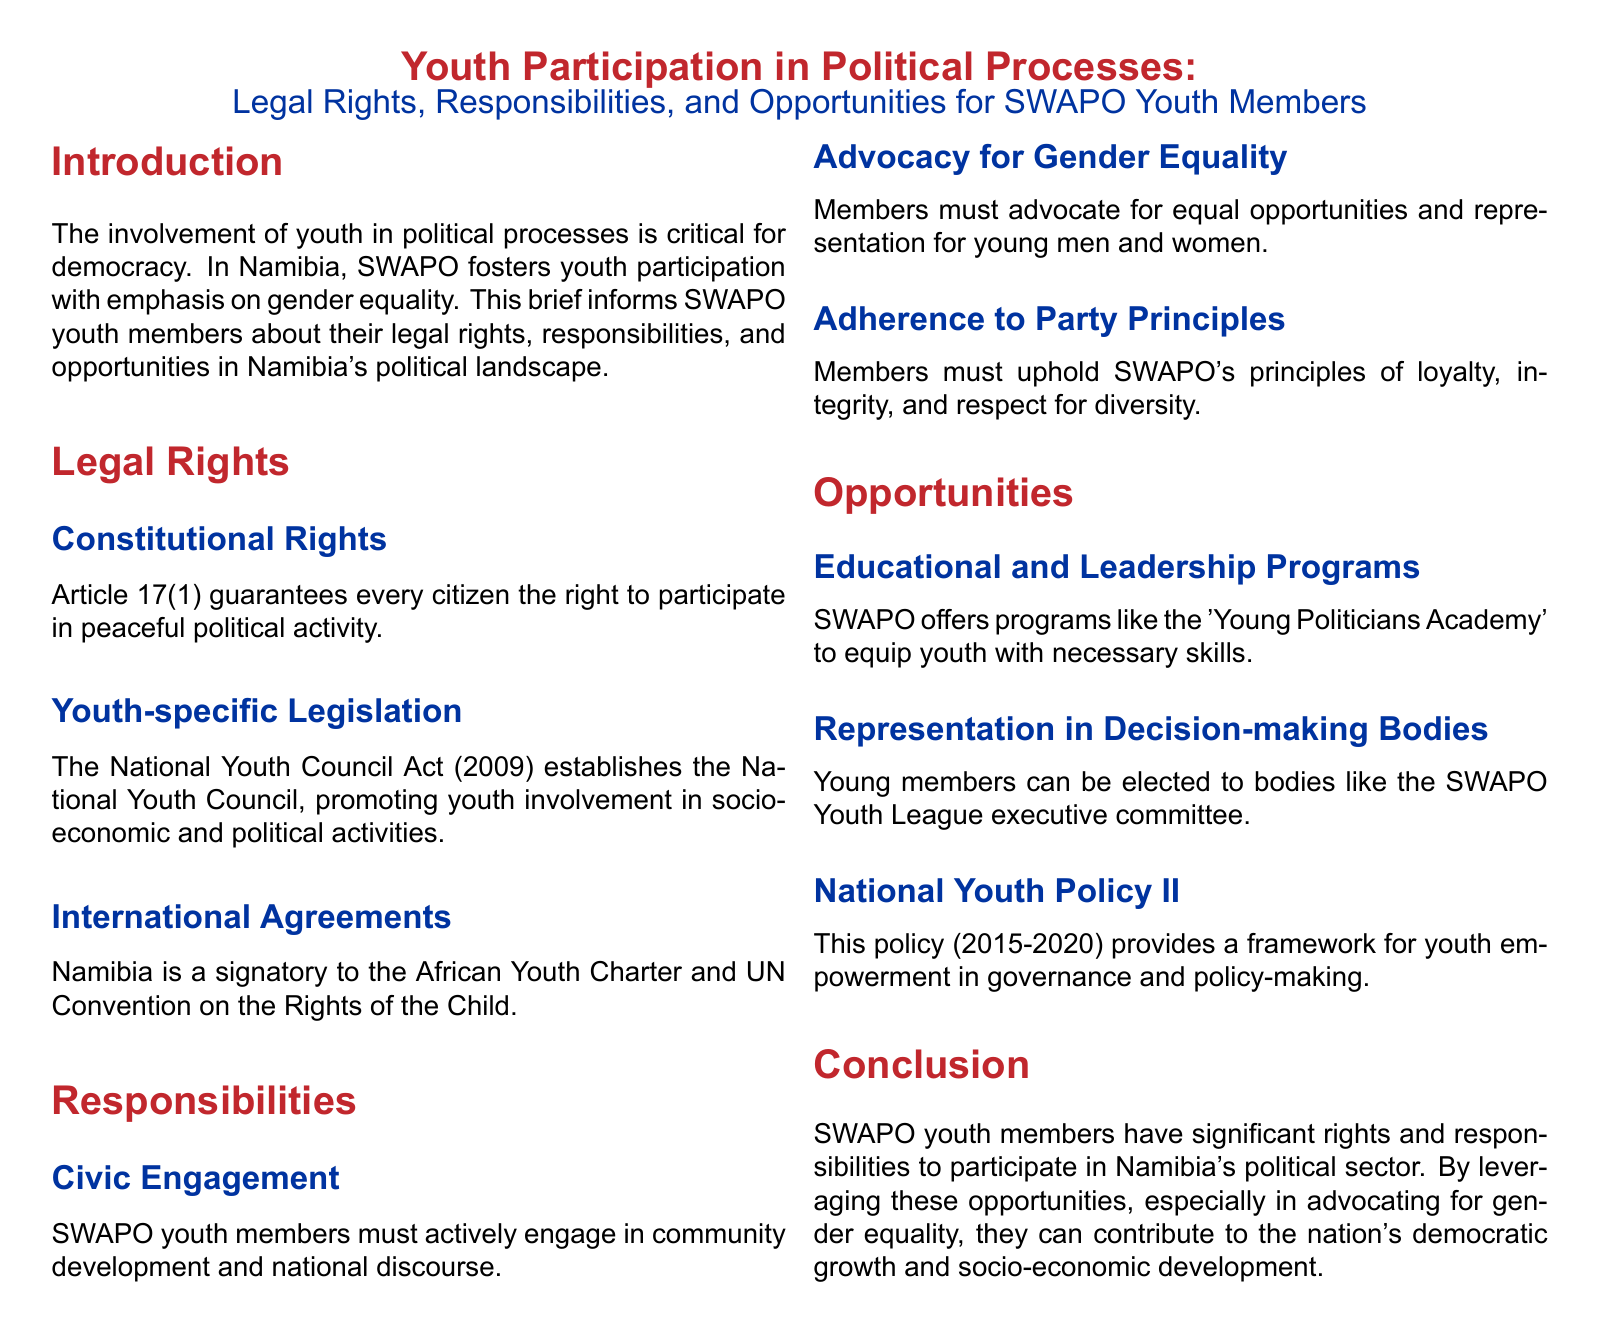What guarantees citizens the right to political activity? Article 17(1) of the Namibian Constitution guarantees every citizen the right to participate in peaceful political activity.
Answer: Article 17(1) What act promotes youth involvement in socio-economic and political activities? The National Youth Council Act (2009) establishes the National Youth Council, promoting youth involvement in socio-economic and political activities.
Answer: National Youth Council Act (2009) Which international agreement relates to the rights of children? Namibia is a signatory to the UN Convention on the Rights of the Child, which outlines rights for youth.
Answer: UN Convention on the Rights of the Child What program does SWAPO offer for youth to learn leadership skills? The 'Young Politicians Academy' is a program offered by SWAPO to equip youth with necessary skills.
Answer: Young Politicians Academy What should SWAPO youth members advocate for regarding gender? Members must advocate for equal opportunities and representation for young men and women, emphasizing gender equality.
Answer: Gender equality How long is the National Youth Policy II in effect? The National Youth Policy II is in effect from 2015 to 2020, providing a framework for youth empowerment.
Answer: 2015-2020 What party principles must SWAPO youth members uphold? Members must uphold principles of loyalty, integrity, and respect for diversity as mandated by SWAPO.
Answer: Loyalty, integrity, respect for diversity What is a responsibility of SWAPO youth members? SWAPO youth members must actively engage in community development and national discourse.
Answer: Civic engagement Which body can young members be elected to? Young members can be elected to the SWAPO Youth League executive committee.
Answer: SWAPO Youth League executive committee 